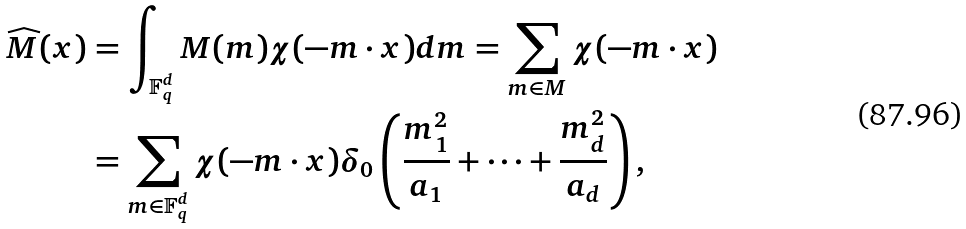Convert formula to latex. <formula><loc_0><loc_0><loc_500><loc_500>\widehat { M } ( x ) & = \int _ { \mathbb { F } _ { q } ^ { d } } M ( m ) \chi ( - m \cdot x ) d m = \sum _ { m \in M } \chi ( - m \cdot x ) \\ & = \sum _ { m \in { \mathbb { F } _ { q } ^ { d } } } \chi ( - m \cdot x ) \delta _ { 0 } \left ( \frac { m _ { 1 } ^ { 2 } } { a _ { 1 } } + \cdots + \frac { m _ { d } ^ { 2 } } { a _ { d } } \right ) ,</formula> 